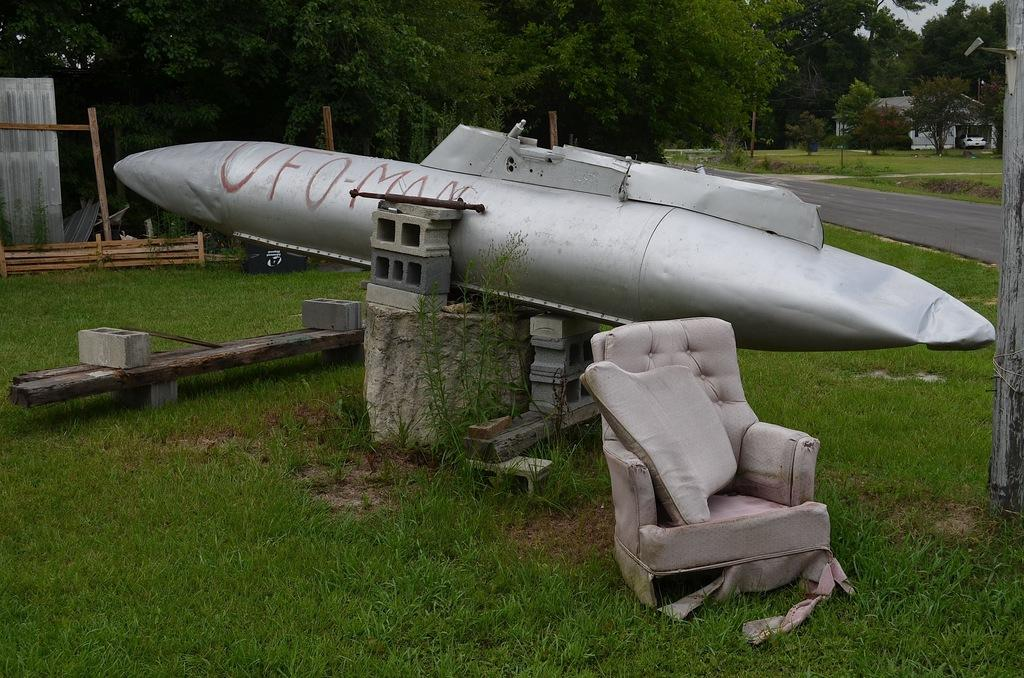What object in the image appears to be damaged or broken? There is a broken chair in the image. What is the main subject of the image? The image appears to depict a part of a rocket. What type of natural environment can be seen in the background of the image? There are trees in the background of the image. What type of man-made structure is visible in the background of the image? There is a building in the background of the image. What type of transportation infrastructure can be seen in the background of the image? A road is visible in the background of the image. What type of pet can be seen fearing the broken chair in the image? There is no pet present in the image, and therefore no such interaction can be observed. 